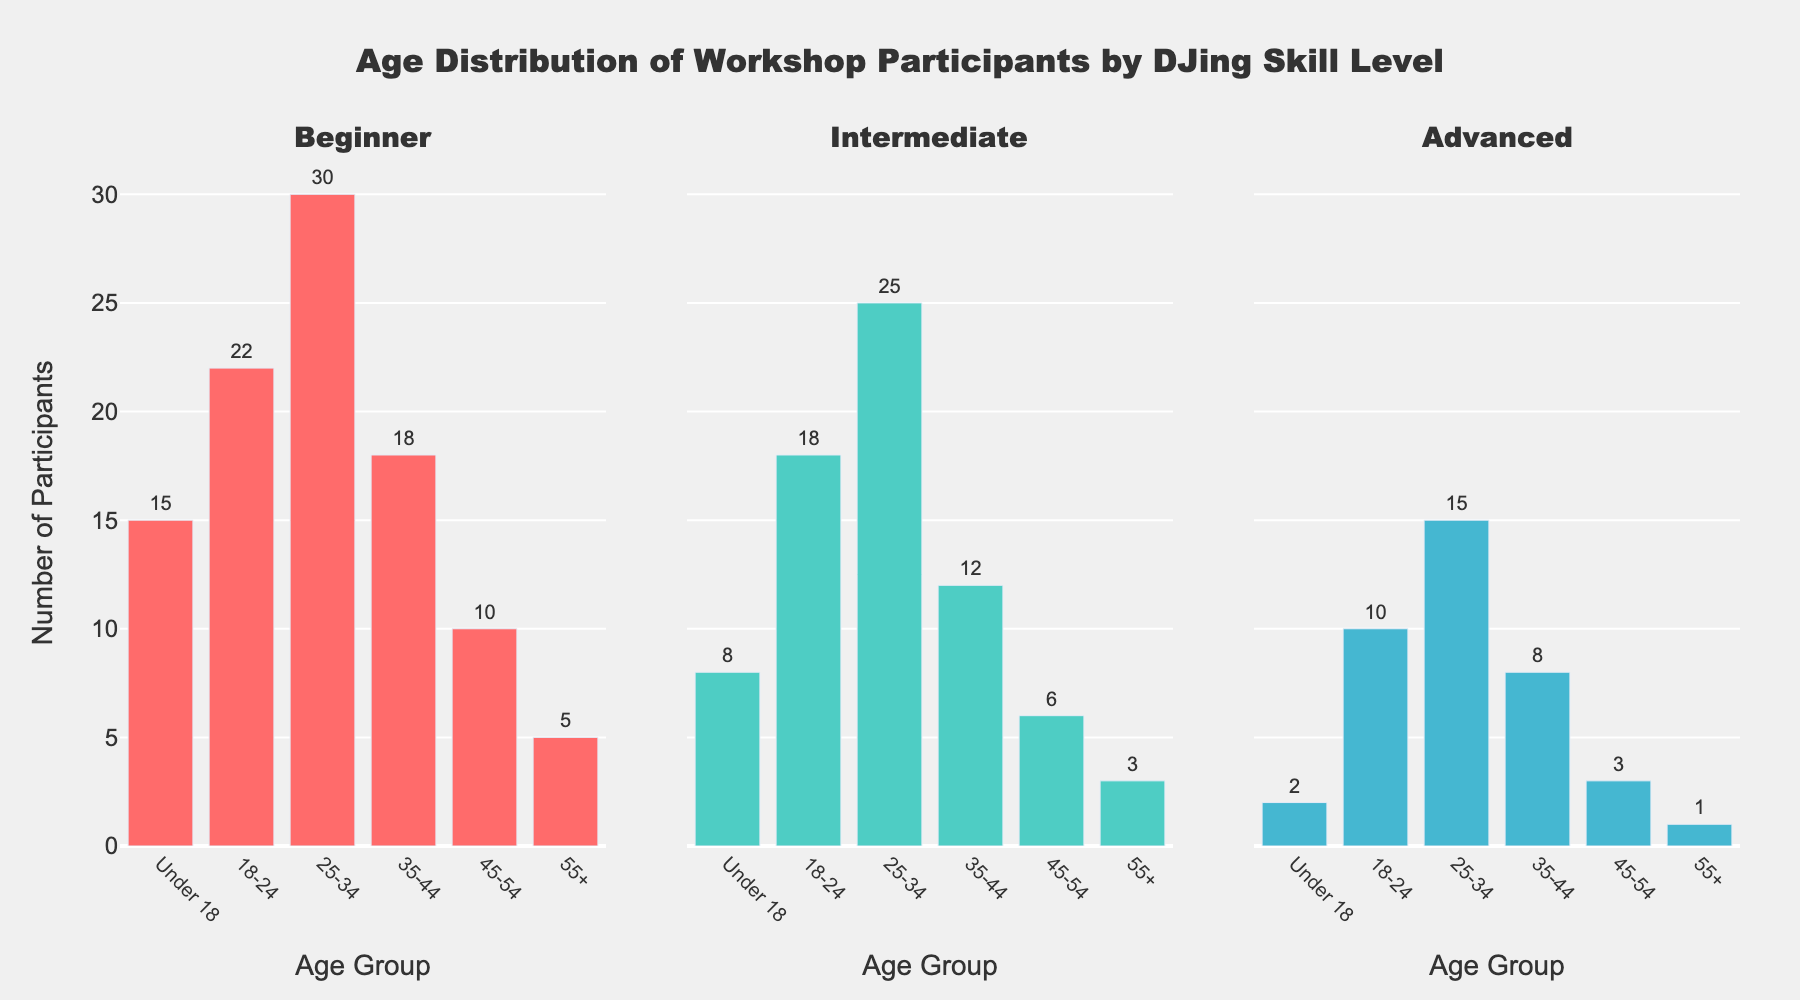What is the title of the figure? The title is displayed at the top of the figure and indicates what the figure is about. The title reads "Age Distribution of Workshop Participants by DJing Skill Level."
Answer: Age Distribution of Workshop Participants by DJing Skill Level Which age group has the highest number of beginner participants? Look at the first subplot representing beginners and identify the age group with the highest bar. The '25-34' age group has the tallest bar.
Answer: 25-34 How many participants are there in the '45-54' age group for the advanced skill level? Check the third subplot for the 'Advanced' category, then look for the bar labeled '45-54'. The bar represents 3 participants.
Answer: 3 Which age group has the fewest intermediate participants? Look at the second subplot for 'Intermediate' and identify the age group with the shortest bar. The '55+' age group has the shortest bar with 3 participants.
Answer: 55+ What is the combined total number of participants in the '18-24' age group across all skill levels? Add up the '18-24' participants from all three subplots: Beginner (22) + Intermediate (18) + Advanced (10). The total is 22 + 18 + 10 = 50.
Answer: 50 Compare the number of participants in the '35-44' age group between beginners and intermediates. Are there more beginner participants or intermediate participants? Check the subplots for both 'Beginner' and 'Intermediate'. The '35-44' group has 18 beginners and 12 intermediates. Since 18 > 12, there are more beginners.
Answer: More beginners What is the average number of participants in the '25-34' age group across all skill levels? Add the '25-34' participants and divide by the number of skill levels: Beginner (30) + Intermediate (25) + Advanced (15). Average = (30 + 25 + 15) / 3 = 70 / 3 ≈ 23.33.
Answer: 23.33 In which skill level does the 'Under 18' age group have the fewest participants? Compare the 'Under 18' bars across all three skill levels' subplots. The advanced level has the fewest participants with 2.
Answer: Advanced Which two age groups have the closest number of participants in the 'Intermediate' skill level? Look at the intermediate subplot and compare the heights of the bars. The '18-24' group has 18 participants and the '25-34' group has 25 participants. These numbers are relatively close compared to other group differences.
Answer: 18-24 and 25-34 